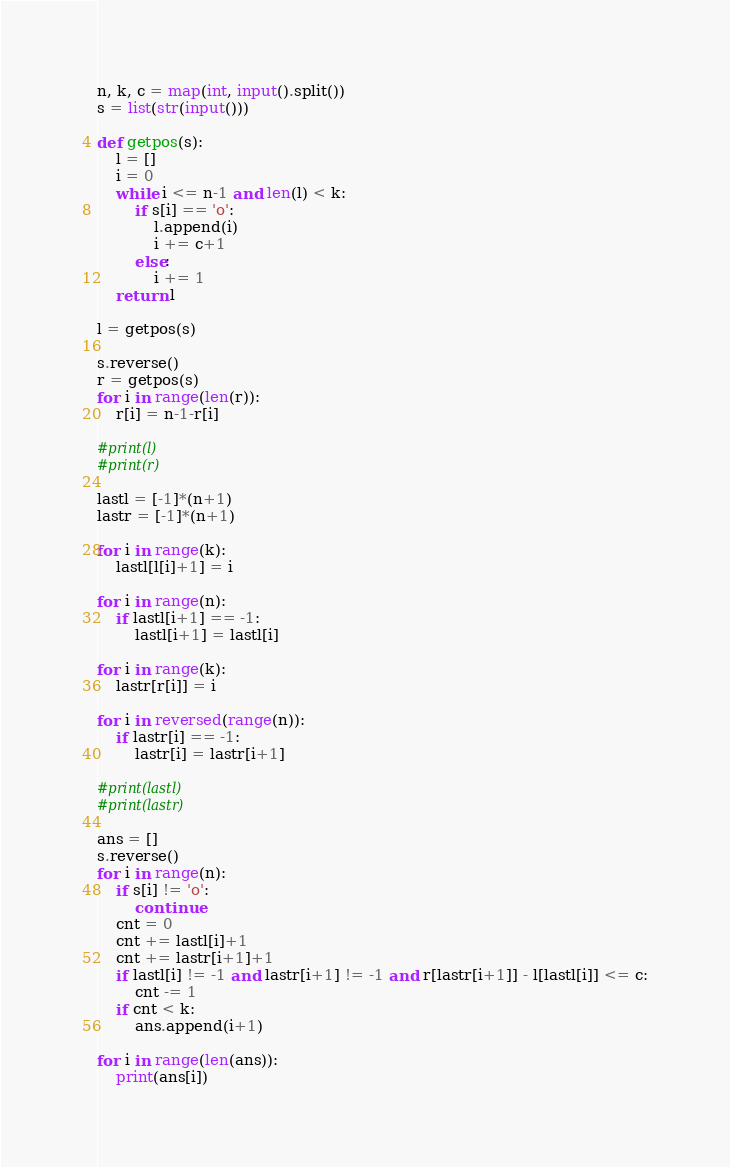Convert code to text. <code><loc_0><loc_0><loc_500><loc_500><_Python_>n, k, c = map(int, input().split())
s = list(str(input()))

def getpos(s):
    l = []
    i = 0
    while i <= n-1 and len(l) < k:
        if s[i] == 'o':
            l.append(i)
            i += c+1
        else:
            i += 1
    return l

l = getpos(s)

s.reverse()
r = getpos(s)
for i in range(len(r)):
    r[i] = n-1-r[i]

#print(l)
#print(r)

lastl = [-1]*(n+1)
lastr = [-1]*(n+1)

for i in range(k):
    lastl[l[i]+1] = i

for i in range(n):
    if lastl[i+1] == -1:
        lastl[i+1] = lastl[i]

for i in range(k):
    lastr[r[i]] = i

for i in reversed(range(n)):
    if lastr[i] == -1:
        lastr[i] = lastr[i+1]

#print(lastl)
#print(lastr)

ans = []
s.reverse()
for i in range(n):
    if s[i] != 'o':
        continue
    cnt = 0
    cnt += lastl[i]+1
    cnt += lastr[i+1]+1
    if lastl[i] != -1 and lastr[i+1] != -1 and r[lastr[i+1]] - l[lastl[i]] <= c:
        cnt -= 1
    if cnt < k:
        ans.append(i+1)

for i in range(len(ans)):
    print(ans[i])</code> 